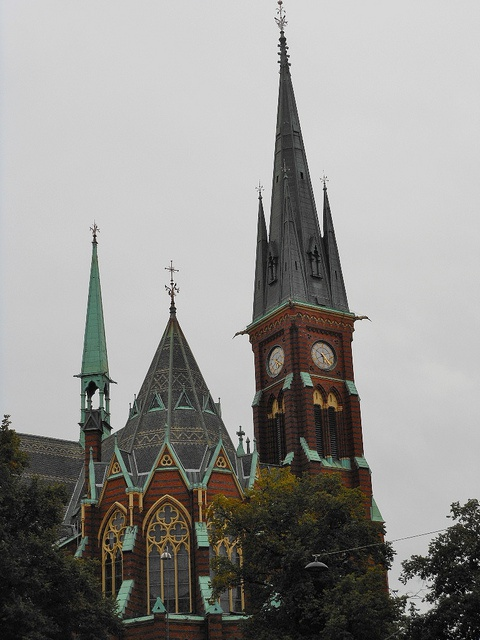Describe the objects in this image and their specific colors. I can see clock in lightgray and gray tones and clock in lightgray, gray, and black tones in this image. 